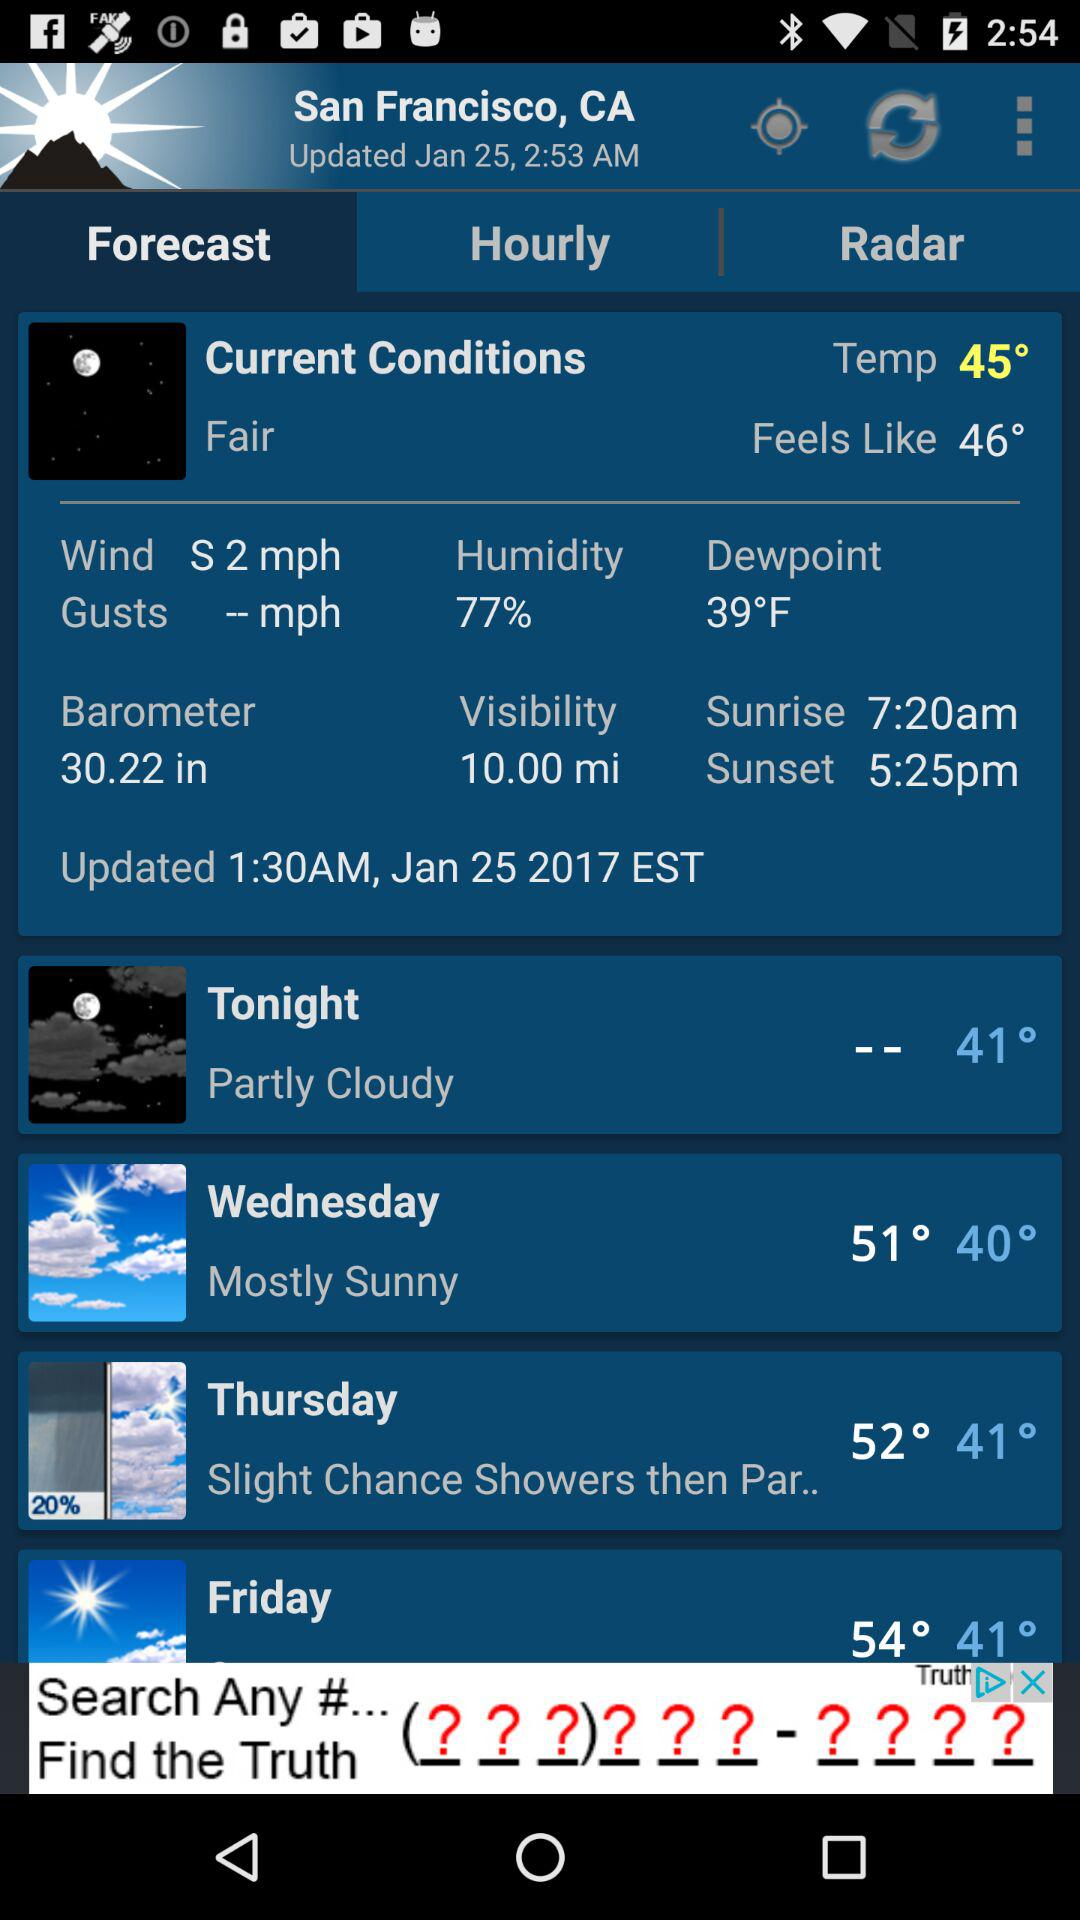What's the humidity percentage? The humidity percentage is 77. 